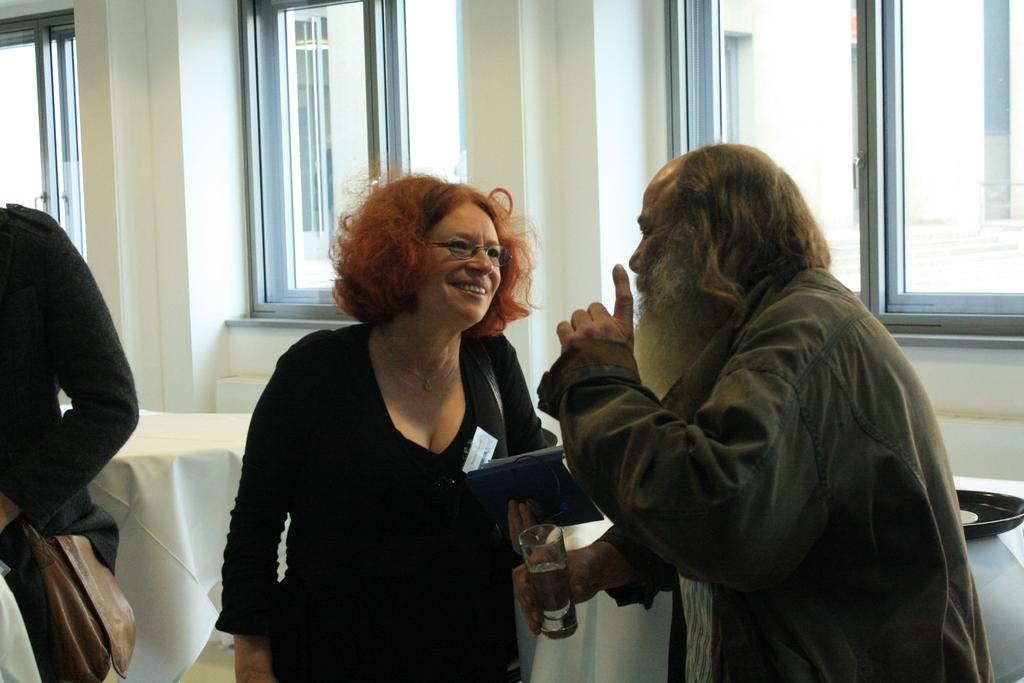What type of structure can be seen in the image? There is a wall in the image. Are there any openings in the wall? Yes, there are windows in the image. Who or what can be seen in the image? There are people in the image. What type of furniture is present in the image? There are tables in the image. What is placed on one of the tables? There is a white cloth on a table. What else is on the table with the white cloth? There is a bowl on a table. What type of coach can be seen in the image? There is no coach present in the image. What material is the steel used for in the image? There is no steel present in the image. 